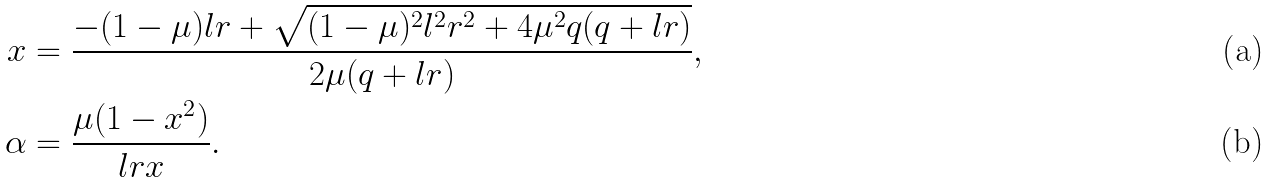<formula> <loc_0><loc_0><loc_500><loc_500>x & = \frac { - ( 1 - \mu ) l r + \sqrt { ( 1 - \mu ) ^ { 2 } l ^ { 2 } r ^ { 2 } + 4 \mu ^ { 2 } q ( q + l r ) } } { 2 \mu ( q + l r ) } , \\ \alpha & = \frac { \mu ( 1 - x ^ { 2 } ) } { l r x } .</formula> 